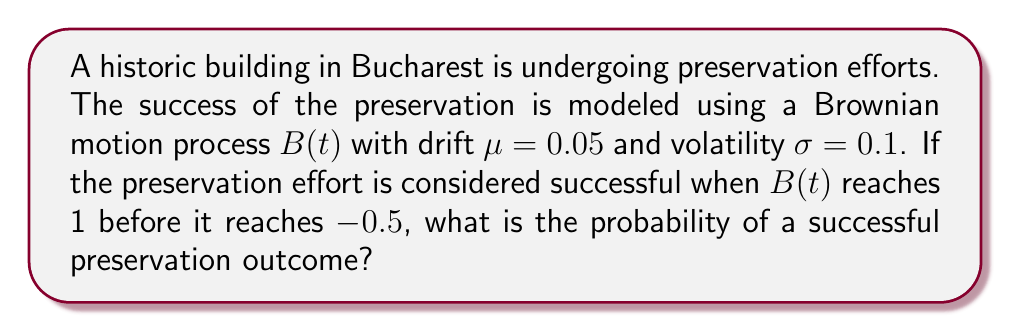Help me with this question. To solve this problem, we'll use the concept of hitting probabilities in Brownian motion with drift. Let's approach this step-by-step:

1) In this case, we have a Brownian motion with drift $\mu = 0.05$ and volatility $\sigma = 0.1$.

2) We want to find the probability of reaching 1 before -0.5, starting from 0.

3) For a Brownian motion with drift, the probability of hitting an upper barrier $b$ before a lower barrier $a$, starting from $x$, is given by:

   $$P(x) = \frac{e^{-2\mu a/\sigma^2} - e^{-2\mu x/\sigma^2}}{e^{-2\mu a/\sigma^2} - e^{-2\mu b/\sigma^2}}$$

4) In our case:
   $a = -0.5$ (lower barrier)
   $b = 1$ (upper barrier)
   $x = 0$ (starting point)
   $\mu = 0.05$
   $\sigma = 0.1$

5) Let's substitute these values:

   $$P(0) = \frac{e^{-2(0.05)(-0.5)/(0.1)^2} - e^{-2(0.05)(0)/(0.1)^2}}{e^{-2(0.05)(-0.5)/(0.1)^2} - e^{-2(0.05)(1)/(0.1)^2}}$$

6) Simplify:
   $$P(0) = \frac{e^{5} - 1}{e^{5} - e^{-10}}$$

7) Calculate:
   $$P(0) \approx 0.9992$$

Therefore, the probability of a successful preservation outcome is approximately 0.9992 or 99.92%.
Answer: 0.9992 